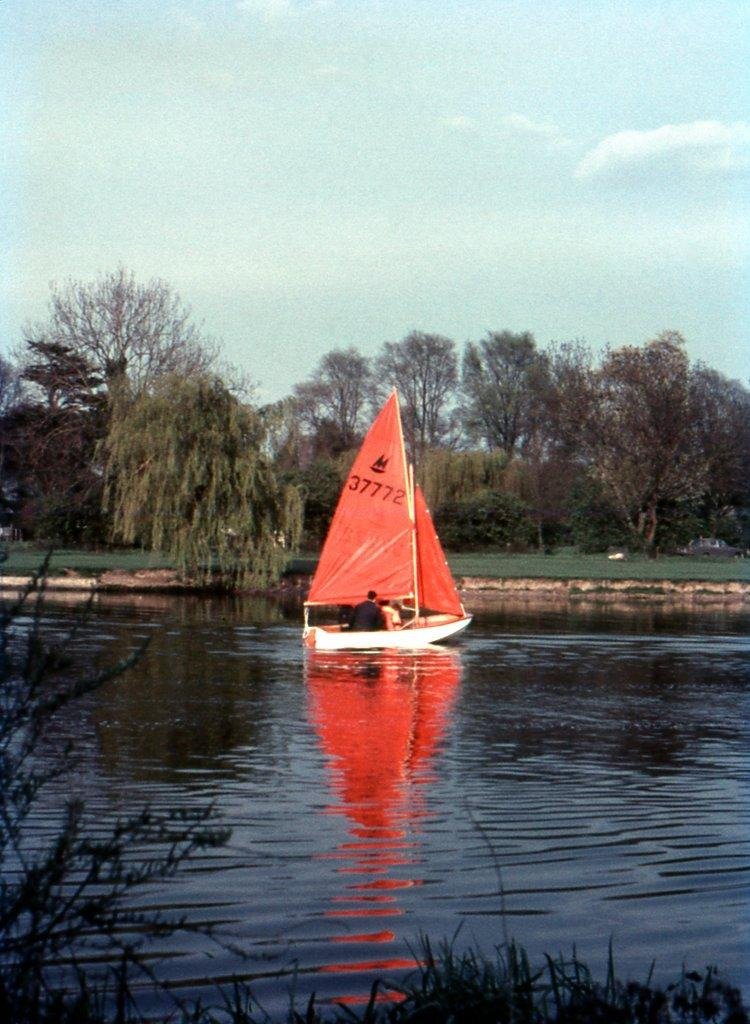What is the main subject of the image? The main subject of the image is a boat. Where is the boat located? The boat is on the water. Are there any people in the boat? Yes, there are people in the boat. What can be seen in the background of the image? In the background of the image, there is grass, plants, trees, and the sky. What is the condition of the sky in the image? The sky is visible in the background of the image, and there are clouds present. How many geese are flying in formation above the boat in the image? There are no geese present in the image; it only features a boat on the water with people in it, surrounded by a natural background. 